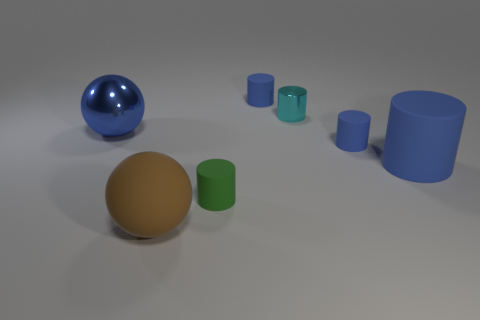How big is the cylinder that is both to the left of the small cyan metallic cylinder and behind the green cylinder? In the image, you can see several cylinders, but focusing on the described one, we notice there is no cylinder that satisfies all three conditions of being to the left of a small cyan metallic cylinder, being smaller than the cyan cylinder, and situated behind the green cylinder. Therefore, it is not possible to determine the size as the conditions don't point to an existing object in the scene. 